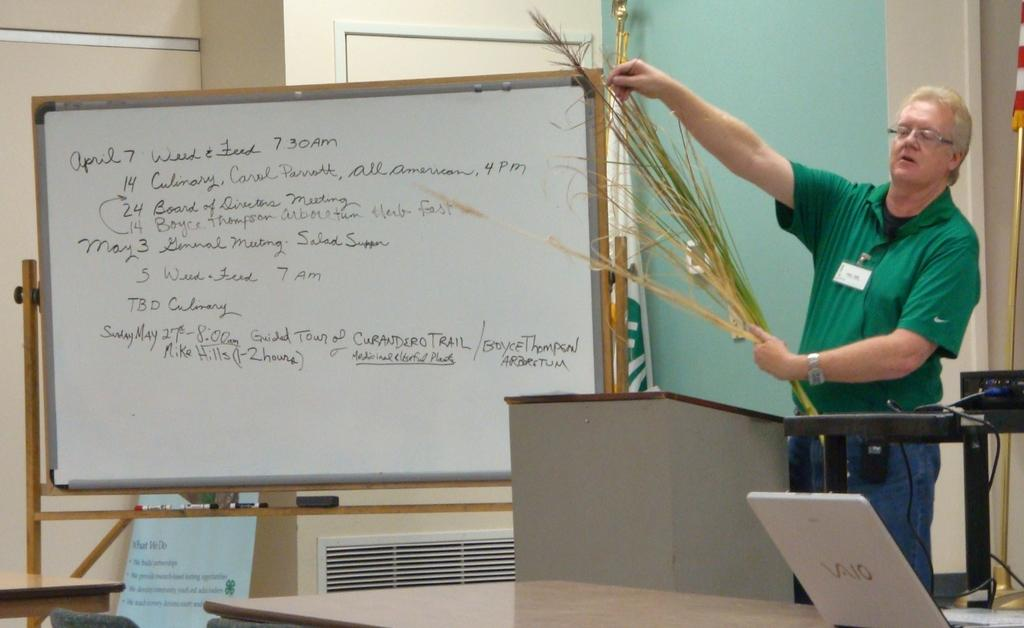<image>
Provide a brief description of the given image. A white board has the date April 7th on the top. 